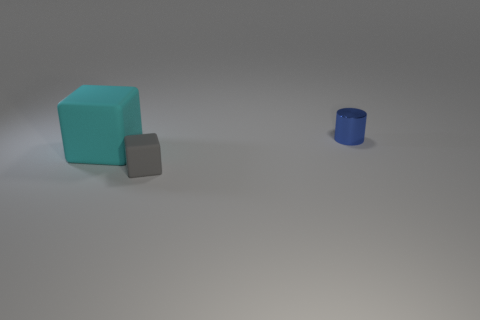Add 1 cyan rubber objects. How many objects exist? 4 Subtract all cylinders. How many objects are left? 2 Subtract all purple cubes. Subtract all purple spheres. How many cubes are left? 2 Subtract all cyan rubber blocks. Subtract all tiny shiny things. How many objects are left? 1 Add 2 gray blocks. How many gray blocks are left? 3 Add 1 tiny matte balls. How many tiny matte balls exist? 1 Subtract 0 cyan spheres. How many objects are left? 3 